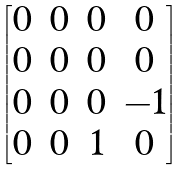Convert formula to latex. <formula><loc_0><loc_0><loc_500><loc_500>\begin{bmatrix} 0 & 0 & 0 & 0 \\ 0 & 0 & 0 & 0 \\ 0 & 0 & 0 & - 1 \\ 0 & 0 & 1 & 0 \end{bmatrix}</formula> 